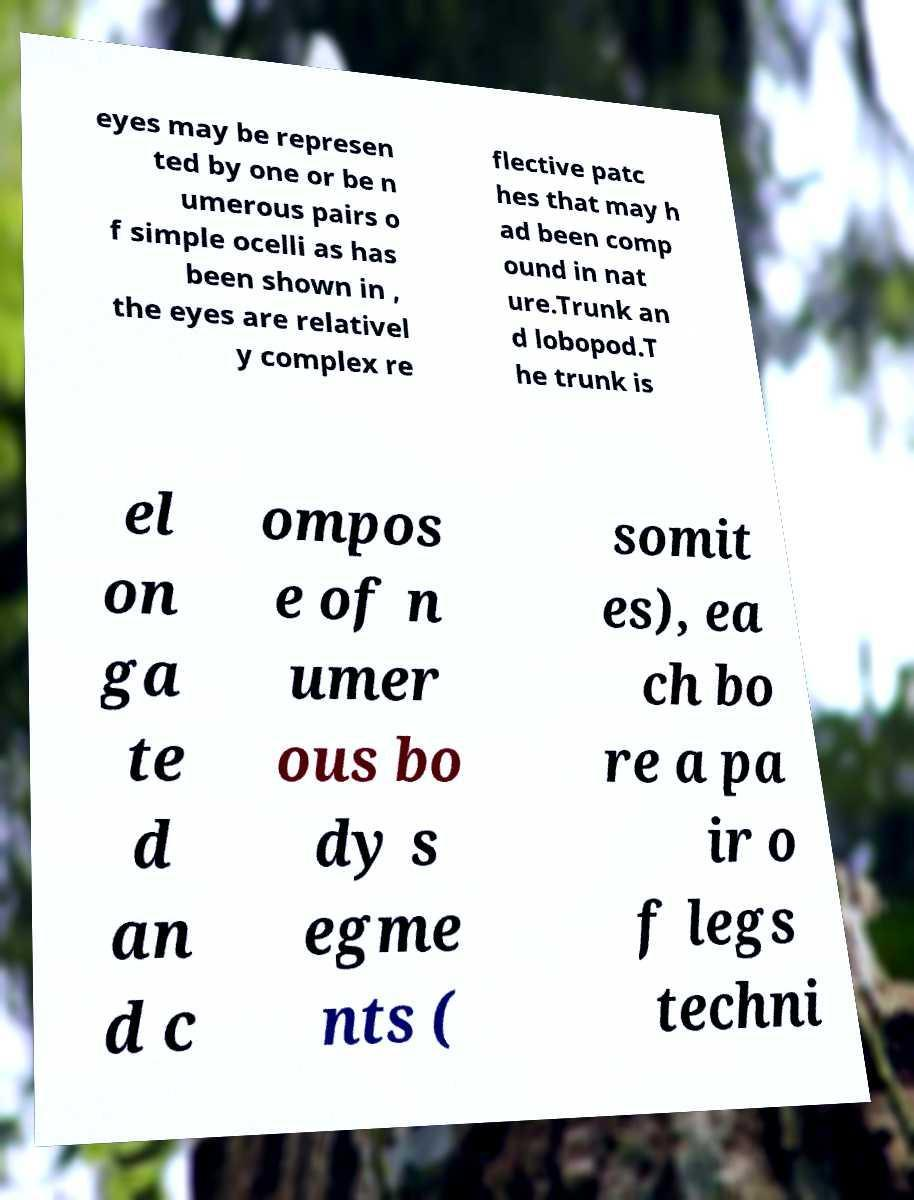What messages or text are displayed in this image? I need them in a readable, typed format. eyes may be represen ted by one or be n umerous pairs o f simple ocelli as has been shown in , the eyes are relativel y complex re flective patc hes that may h ad been comp ound in nat ure.Trunk an d lobopod.T he trunk is el on ga te d an d c ompos e of n umer ous bo dy s egme nts ( somit es), ea ch bo re a pa ir o f legs techni 